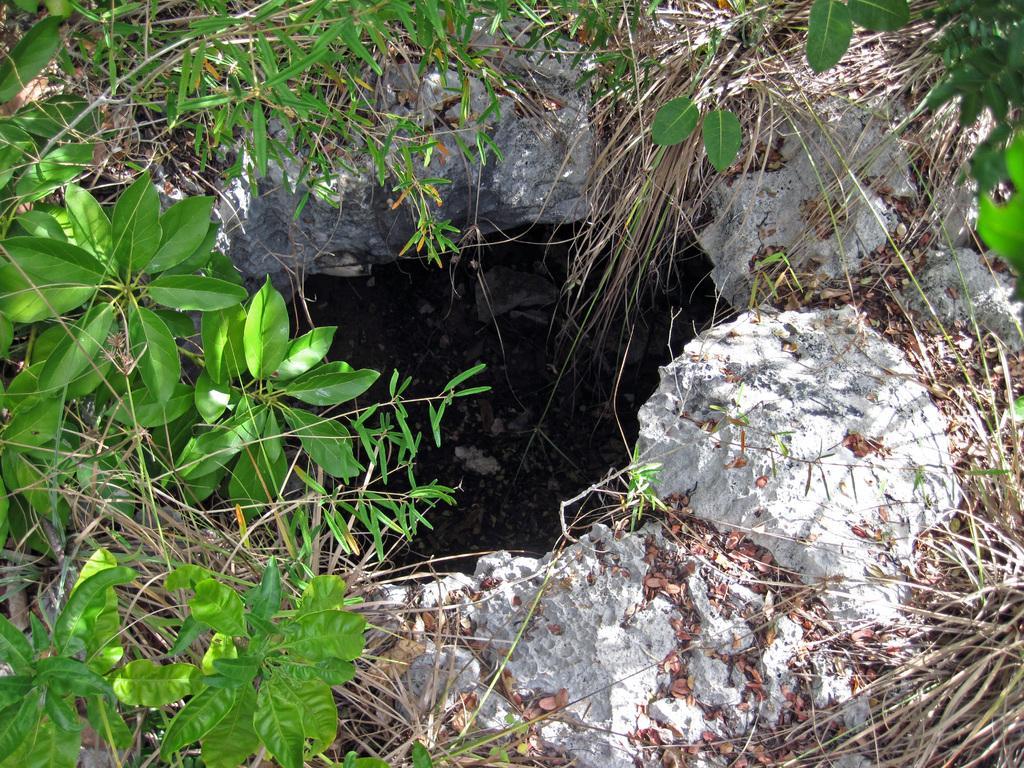Describe this image in one or two sentences. In this picture there are plants, dry grass, stones and a pit. 